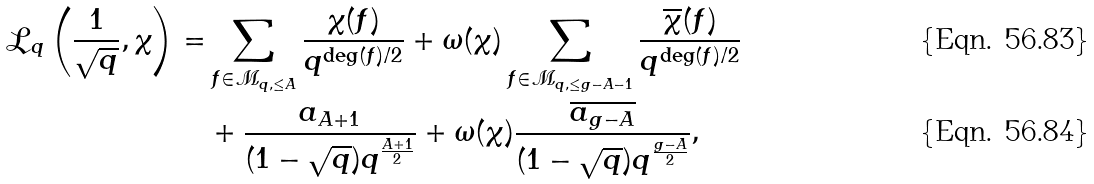Convert formula to latex. <formula><loc_0><loc_0><loc_500><loc_500>\mathcal { L } _ { q } \left ( \frac { 1 } { \sqrt { q } } , \chi \right ) = & \sum _ { f \in \mathcal { M } _ { q , \leq A } } \frac { \chi ( f ) } { q ^ { \deg ( f ) / 2 } } + \omega ( \chi ) \sum _ { f \in \mathcal { M } _ { q , \leq g - A - 1 } } \frac { \overline { \chi } ( f ) } { q ^ { \deg ( f ) / 2 } } \\ & + \frac { a _ { A + 1 } } { ( 1 - \sqrt { q } ) q ^ { \frac { A + 1 } { 2 } } } + \omega ( \chi ) \frac { \overline { a _ { g - A } } } { ( 1 - \sqrt { q } ) q ^ { \frac { g - A } { 2 } } } ,</formula> 